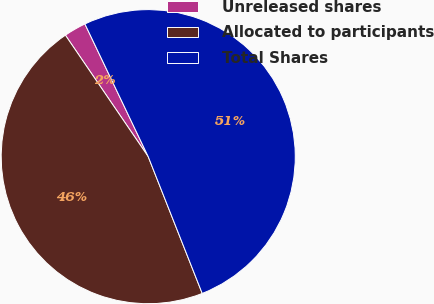<chart> <loc_0><loc_0><loc_500><loc_500><pie_chart><fcel>Unreleased shares<fcel>Allocated to participants<fcel>Total Shares<nl><fcel>2.44%<fcel>46.46%<fcel>51.1%<nl></chart> 